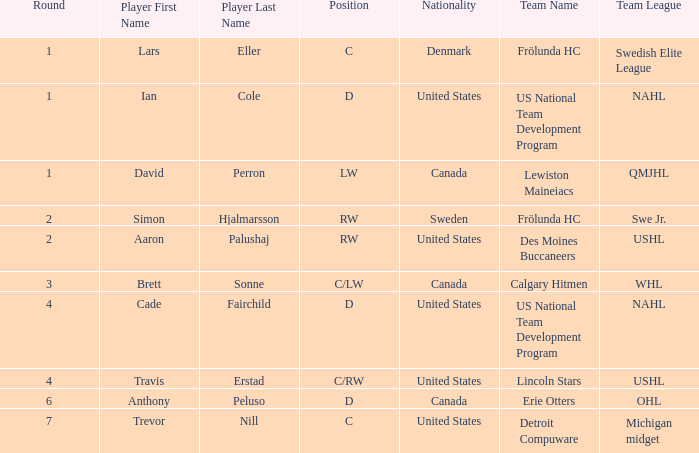What is the position of the player from round 2 from Sweden? RW. Give me the full table as a dictionary. {'header': ['Round', 'Player First Name', 'Player Last Name', 'Position', 'Nationality', 'Team Name', 'Team League'], 'rows': [['1', 'Lars', 'Eller', 'C', 'Denmark', 'Frölunda HC', 'Swedish Elite League'], ['1', 'Ian', 'Cole', 'D', 'United States', 'US National Team Development Program', 'NAHL'], ['1', 'David', 'Perron', 'LW', 'Canada', 'Lewiston Maineiacs', 'QMJHL'], ['2', 'Simon', 'Hjalmarsson', 'RW', 'Sweden', 'Frölunda HC', 'Swe Jr.'], ['2', 'Aaron', 'Palushaj', 'RW', 'United States', 'Des Moines Buccaneers', 'USHL'], ['3', 'Brett', 'Sonne', 'C/LW', 'Canada', 'Calgary Hitmen', 'WHL'], ['4', 'Cade', 'Fairchild', 'D', 'United States', 'US National Team Development Program', 'NAHL'], ['4', 'Travis', 'Erstad', 'C/RW', 'United States', 'Lincoln Stars', 'USHL'], ['6', 'Anthony', 'Peluso', 'D', 'Canada', 'Erie Otters', 'OHL'], ['7', 'Trevor', 'Nill', 'C', 'United States', 'Detroit Compuware', 'Michigan midget']]} 